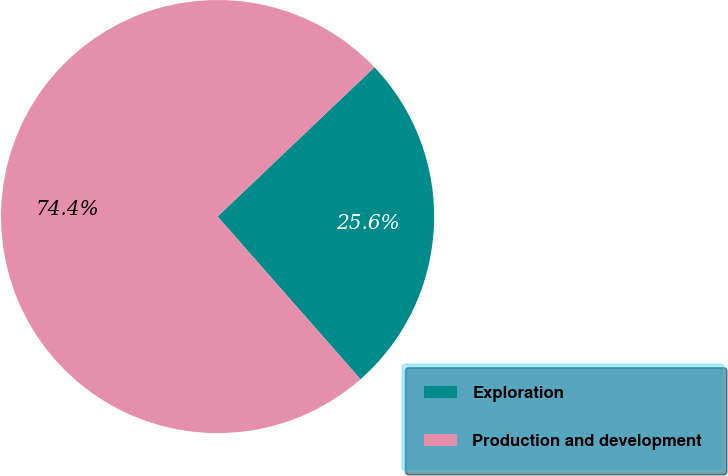Convert chart to OTSL. <chart><loc_0><loc_0><loc_500><loc_500><pie_chart><fcel>Exploration<fcel>Production and development<nl><fcel>25.64%<fcel>74.36%<nl></chart> 